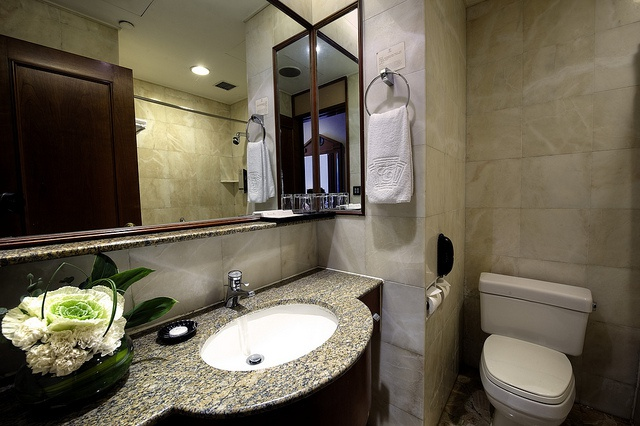Describe the objects in this image and their specific colors. I can see potted plant in black, ivory, khaki, and tan tones, toilet in black, darkgray, and gray tones, and sink in black, white, darkgray, and gray tones in this image. 